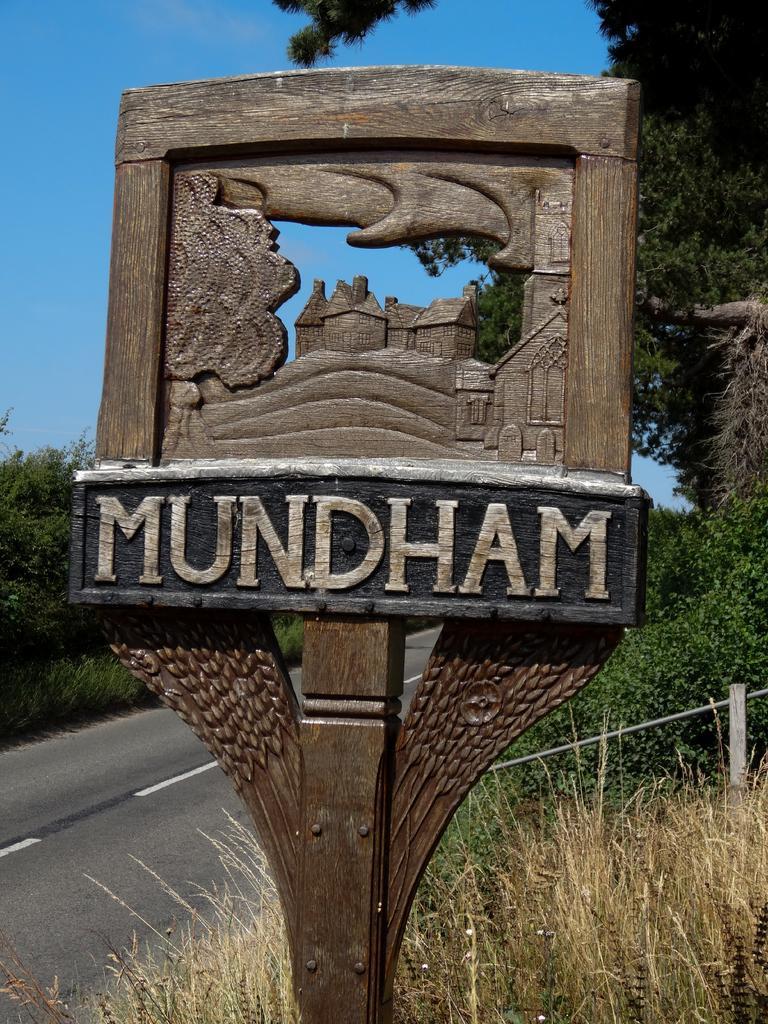Describe this image in one or two sentences. In this image in front there is a wooden board with letters on it. Behind the board there is grass on the surface. In the center of the image there is a road. In the background of the image there are trees and sky. 